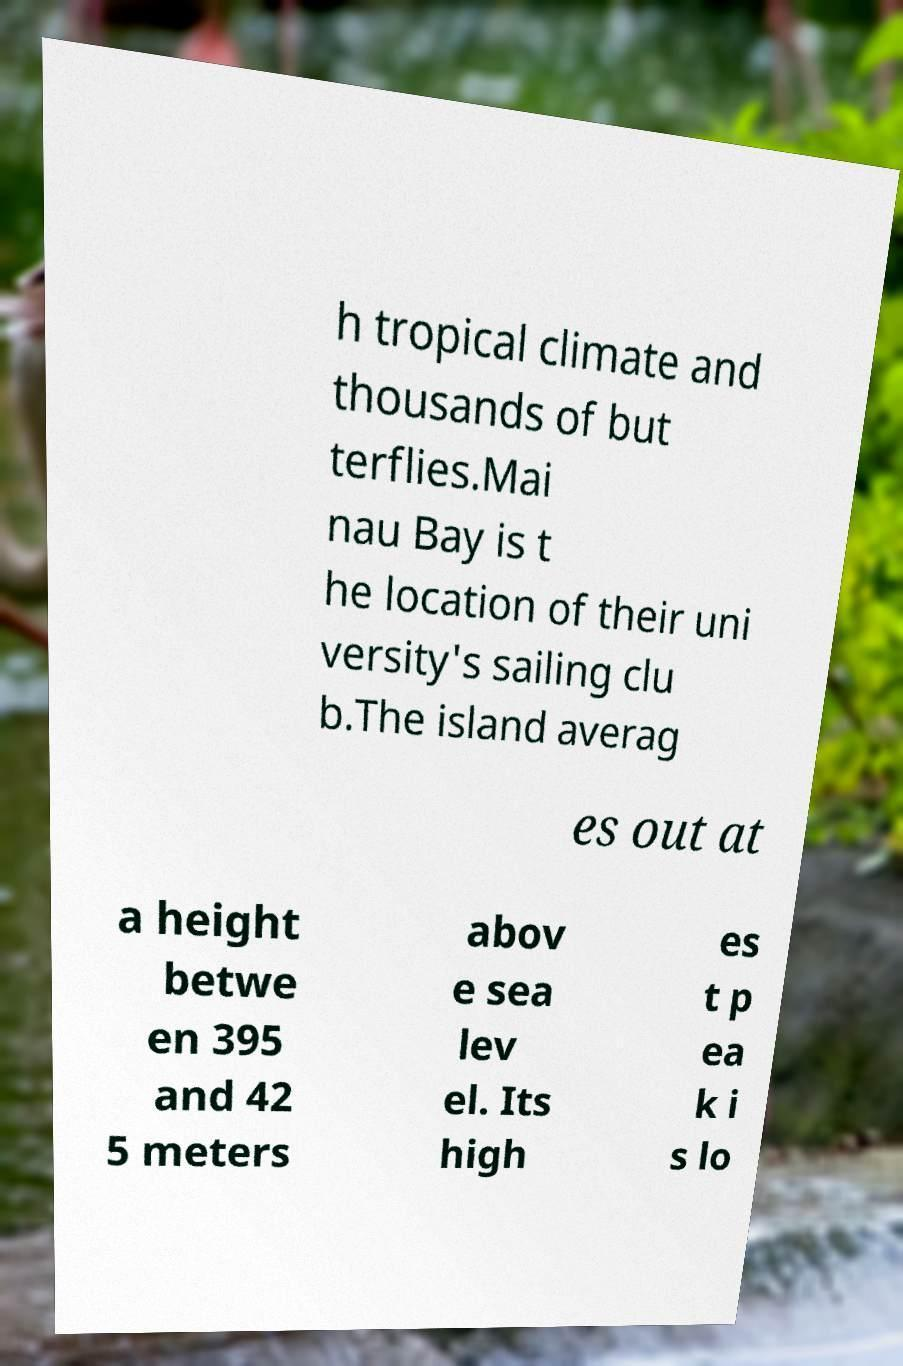Please read and relay the text visible in this image. What does it say? h tropical climate and thousands of but terflies.Mai nau Bay is t he location of their uni versity's sailing clu b.The island averag es out at a height betwe en 395 and 42 5 meters abov e sea lev el. Its high es t p ea k i s lo 